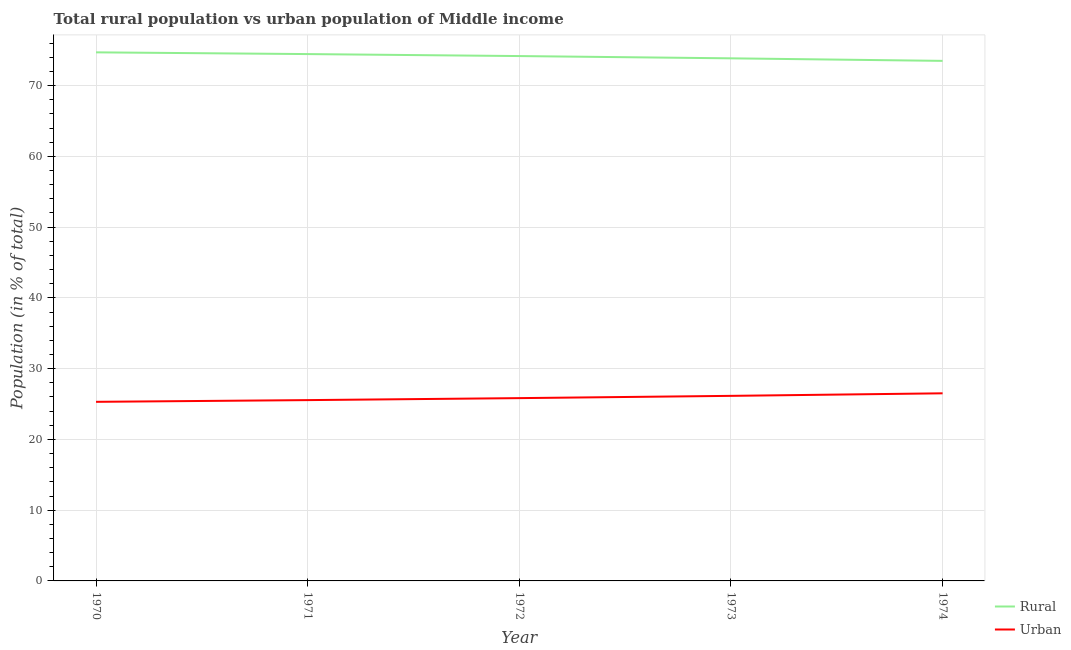Does the line corresponding to rural population intersect with the line corresponding to urban population?
Ensure brevity in your answer.  No. What is the rural population in 1974?
Ensure brevity in your answer.  73.49. Across all years, what is the maximum rural population?
Provide a short and direct response. 74.69. Across all years, what is the minimum urban population?
Offer a very short reply. 25.31. In which year was the urban population maximum?
Give a very brief answer. 1974. In which year was the rural population minimum?
Keep it short and to the point. 1974. What is the total rural population in the graph?
Your answer should be very brief. 370.65. What is the difference between the rural population in 1970 and that in 1973?
Provide a succinct answer. 0.84. What is the difference between the urban population in 1974 and the rural population in 1971?
Give a very brief answer. -47.94. What is the average rural population per year?
Ensure brevity in your answer.  74.13. In the year 1973, what is the difference between the urban population and rural population?
Keep it short and to the point. -47.7. In how many years, is the rural population greater than 4 %?
Your answer should be compact. 5. What is the ratio of the rural population in 1972 to that in 1974?
Your response must be concise. 1.01. What is the difference between the highest and the second highest rural population?
Provide a succinct answer. 0.24. What is the difference between the highest and the lowest urban population?
Your answer should be very brief. 1.2. In how many years, is the rural population greater than the average rural population taken over all years?
Provide a short and direct response. 3. Is the sum of the urban population in 1970 and 1973 greater than the maximum rural population across all years?
Make the answer very short. No. Does the rural population monotonically increase over the years?
Your answer should be compact. No. Is the urban population strictly greater than the rural population over the years?
Your response must be concise. No. Is the rural population strictly less than the urban population over the years?
Your response must be concise. No. How many lines are there?
Offer a terse response. 2. Are the values on the major ticks of Y-axis written in scientific E-notation?
Your answer should be compact. No. Does the graph contain grids?
Your response must be concise. Yes. Where does the legend appear in the graph?
Your response must be concise. Bottom right. What is the title of the graph?
Keep it short and to the point. Total rural population vs urban population of Middle income. Does "Number of arrivals" appear as one of the legend labels in the graph?
Offer a terse response. No. What is the label or title of the X-axis?
Make the answer very short. Year. What is the label or title of the Y-axis?
Make the answer very short. Population (in % of total). What is the Population (in % of total) in Rural in 1970?
Provide a short and direct response. 74.69. What is the Population (in % of total) of Urban in 1970?
Make the answer very short. 25.31. What is the Population (in % of total) of Rural in 1971?
Give a very brief answer. 74.45. What is the Population (in % of total) in Urban in 1971?
Give a very brief answer. 25.55. What is the Population (in % of total) in Rural in 1972?
Offer a very short reply. 74.17. What is the Population (in % of total) in Urban in 1972?
Your response must be concise. 25.83. What is the Population (in % of total) in Rural in 1973?
Ensure brevity in your answer.  73.85. What is the Population (in % of total) in Urban in 1973?
Ensure brevity in your answer.  26.15. What is the Population (in % of total) of Rural in 1974?
Your answer should be very brief. 73.49. What is the Population (in % of total) of Urban in 1974?
Ensure brevity in your answer.  26.51. Across all years, what is the maximum Population (in % of total) in Rural?
Provide a succinct answer. 74.69. Across all years, what is the maximum Population (in % of total) of Urban?
Give a very brief answer. 26.51. Across all years, what is the minimum Population (in % of total) of Rural?
Keep it short and to the point. 73.49. Across all years, what is the minimum Population (in % of total) of Urban?
Offer a very short reply. 25.31. What is the total Population (in % of total) in Rural in the graph?
Give a very brief answer. 370.65. What is the total Population (in % of total) of Urban in the graph?
Provide a short and direct response. 129.35. What is the difference between the Population (in % of total) in Rural in 1970 and that in 1971?
Provide a short and direct response. 0.24. What is the difference between the Population (in % of total) of Urban in 1970 and that in 1971?
Your answer should be compact. -0.24. What is the difference between the Population (in % of total) of Rural in 1970 and that in 1972?
Make the answer very short. 0.52. What is the difference between the Population (in % of total) of Urban in 1970 and that in 1972?
Your answer should be compact. -0.52. What is the difference between the Population (in % of total) in Rural in 1970 and that in 1973?
Offer a very short reply. 0.84. What is the difference between the Population (in % of total) in Urban in 1970 and that in 1973?
Make the answer very short. -0.84. What is the difference between the Population (in % of total) of Rural in 1970 and that in 1974?
Provide a short and direct response. 1.2. What is the difference between the Population (in % of total) of Urban in 1970 and that in 1974?
Your answer should be compact. -1.2. What is the difference between the Population (in % of total) in Rural in 1971 and that in 1972?
Offer a very short reply. 0.28. What is the difference between the Population (in % of total) of Urban in 1971 and that in 1972?
Your answer should be very brief. -0.28. What is the difference between the Population (in % of total) in Rural in 1971 and that in 1973?
Your answer should be very brief. 0.6. What is the difference between the Population (in % of total) in Urban in 1971 and that in 1973?
Make the answer very short. -0.6. What is the difference between the Population (in % of total) of Rural in 1971 and that in 1974?
Make the answer very short. 0.96. What is the difference between the Population (in % of total) in Urban in 1971 and that in 1974?
Offer a terse response. -0.96. What is the difference between the Population (in % of total) of Rural in 1972 and that in 1973?
Make the answer very short. 0.32. What is the difference between the Population (in % of total) in Urban in 1972 and that in 1973?
Your answer should be compact. -0.32. What is the difference between the Population (in % of total) of Rural in 1972 and that in 1974?
Your answer should be compact. 0.68. What is the difference between the Population (in % of total) of Urban in 1972 and that in 1974?
Give a very brief answer. -0.68. What is the difference between the Population (in % of total) of Rural in 1973 and that in 1974?
Make the answer very short. 0.36. What is the difference between the Population (in % of total) in Urban in 1973 and that in 1974?
Offer a very short reply. -0.36. What is the difference between the Population (in % of total) in Rural in 1970 and the Population (in % of total) in Urban in 1971?
Keep it short and to the point. 49.14. What is the difference between the Population (in % of total) in Rural in 1970 and the Population (in % of total) in Urban in 1972?
Ensure brevity in your answer.  48.86. What is the difference between the Population (in % of total) in Rural in 1970 and the Population (in % of total) in Urban in 1973?
Offer a very short reply. 48.54. What is the difference between the Population (in % of total) in Rural in 1970 and the Population (in % of total) in Urban in 1974?
Provide a short and direct response. 48.18. What is the difference between the Population (in % of total) of Rural in 1971 and the Population (in % of total) of Urban in 1972?
Give a very brief answer. 48.62. What is the difference between the Population (in % of total) in Rural in 1971 and the Population (in % of total) in Urban in 1973?
Your answer should be very brief. 48.3. What is the difference between the Population (in % of total) in Rural in 1971 and the Population (in % of total) in Urban in 1974?
Give a very brief answer. 47.94. What is the difference between the Population (in % of total) in Rural in 1972 and the Population (in % of total) in Urban in 1973?
Make the answer very short. 48.02. What is the difference between the Population (in % of total) in Rural in 1972 and the Population (in % of total) in Urban in 1974?
Offer a very short reply. 47.66. What is the difference between the Population (in % of total) of Rural in 1973 and the Population (in % of total) of Urban in 1974?
Ensure brevity in your answer.  47.34. What is the average Population (in % of total) of Rural per year?
Ensure brevity in your answer.  74.13. What is the average Population (in % of total) in Urban per year?
Offer a terse response. 25.87. In the year 1970, what is the difference between the Population (in % of total) in Rural and Population (in % of total) in Urban?
Offer a very short reply. 49.39. In the year 1971, what is the difference between the Population (in % of total) in Rural and Population (in % of total) in Urban?
Your answer should be very brief. 48.9. In the year 1972, what is the difference between the Population (in % of total) in Rural and Population (in % of total) in Urban?
Your response must be concise. 48.34. In the year 1973, what is the difference between the Population (in % of total) in Rural and Population (in % of total) in Urban?
Keep it short and to the point. 47.7. In the year 1974, what is the difference between the Population (in % of total) of Rural and Population (in % of total) of Urban?
Make the answer very short. 46.98. What is the ratio of the Population (in % of total) of Rural in 1970 to that in 1972?
Ensure brevity in your answer.  1.01. What is the ratio of the Population (in % of total) of Urban in 1970 to that in 1972?
Give a very brief answer. 0.98. What is the ratio of the Population (in % of total) of Rural in 1970 to that in 1973?
Your response must be concise. 1.01. What is the ratio of the Population (in % of total) of Rural in 1970 to that in 1974?
Ensure brevity in your answer.  1.02. What is the ratio of the Population (in % of total) of Urban in 1970 to that in 1974?
Keep it short and to the point. 0.95. What is the ratio of the Population (in % of total) in Urban in 1971 to that in 1972?
Keep it short and to the point. 0.99. What is the ratio of the Population (in % of total) in Urban in 1971 to that in 1973?
Your response must be concise. 0.98. What is the ratio of the Population (in % of total) in Rural in 1971 to that in 1974?
Give a very brief answer. 1.01. What is the ratio of the Population (in % of total) in Urban in 1971 to that in 1974?
Make the answer very short. 0.96. What is the ratio of the Population (in % of total) in Urban in 1972 to that in 1973?
Ensure brevity in your answer.  0.99. What is the ratio of the Population (in % of total) of Rural in 1972 to that in 1974?
Offer a very short reply. 1.01. What is the ratio of the Population (in % of total) in Urban in 1972 to that in 1974?
Offer a very short reply. 0.97. What is the ratio of the Population (in % of total) in Rural in 1973 to that in 1974?
Offer a very short reply. 1. What is the ratio of the Population (in % of total) in Urban in 1973 to that in 1974?
Offer a terse response. 0.99. What is the difference between the highest and the second highest Population (in % of total) in Rural?
Ensure brevity in your answer.  0.24. What is the difference between the highest and the second highest Population (in % of total) in Urban?
Make the answer very short. 0.36. What is the difference between the highest and the lowest Population (in % of total) of Rural?
Offer a very short reply. 1.2. What is the difference between the highest and the lowest Population (in % of total) in Urban?
Make the answer very short. 1.2. 